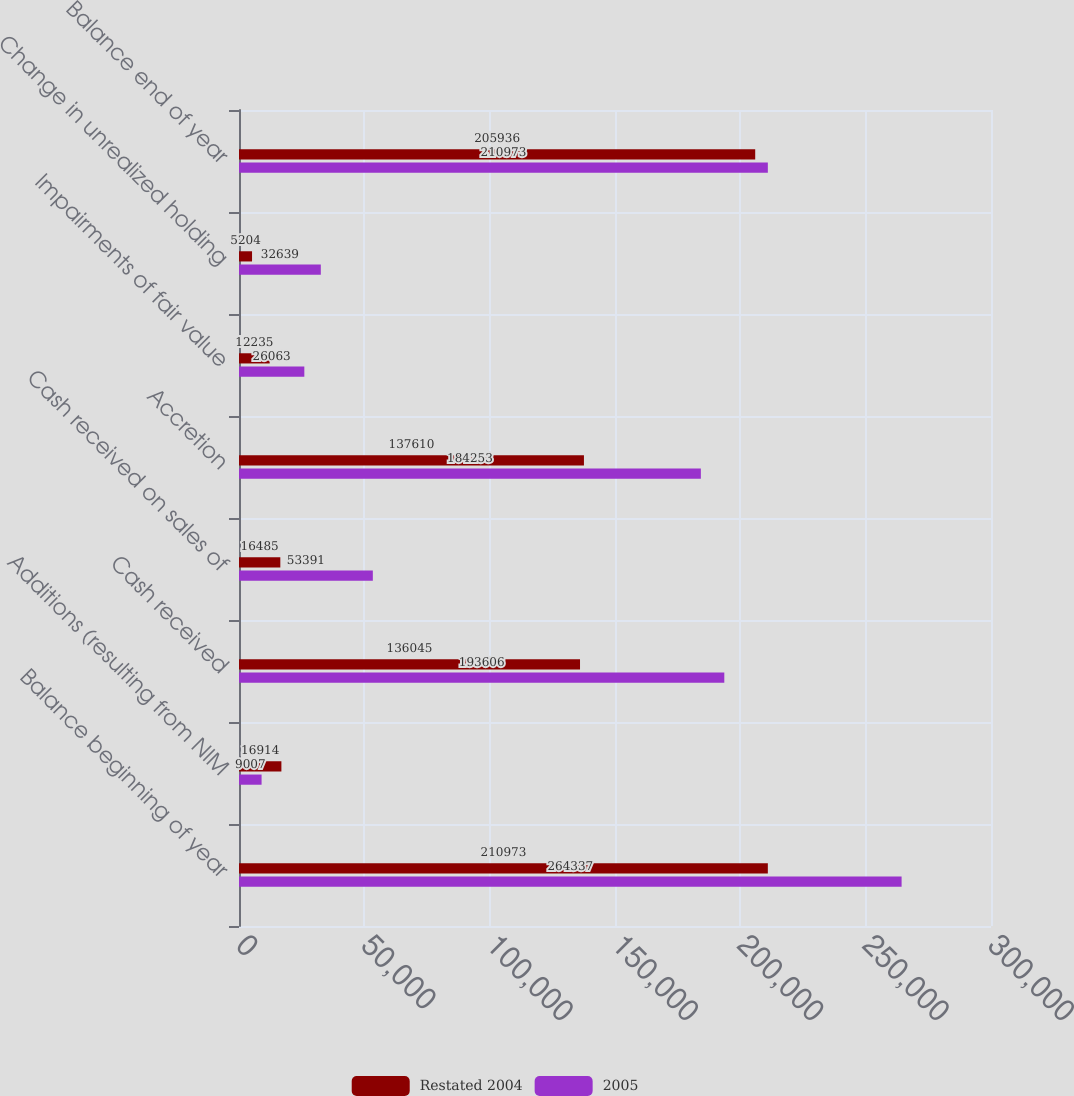Convert chart. <chart><loc_0><loc_0><loc_500><loc_500><stacked_bar_chart><ecel><fcel>Balance beginning of year<fcel>Additions (resulting from NIM<fcel>Cash received<fcel>Cash received on sales of<fcel>Accretion<fcel>Impairments of fair value<fcel>Change in unrealized holding<fcel>Balance end of year<nl><fcel>Restated 2004<fcel>210973<fcel>16914<fcel>136045<fcel>16485<fcel>137610<fcel>12235<fcel>5204<fcel>205936<nl><fcel>2005<fcel>264337<fcel>9007<fcel>193606<fcel>53391<fcel>184253<fcel>26063<fcel>32639<fcel>210973<nl></chart> 